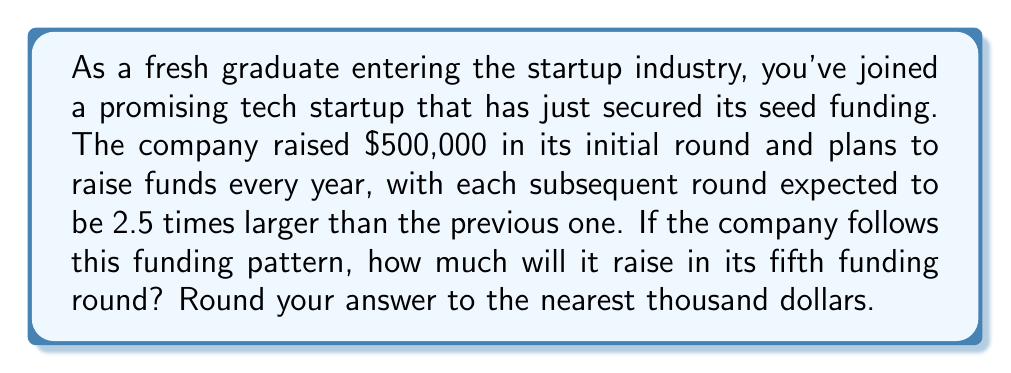Teach me how to tackle this problem. Let's approach this problem using a geometric sequence:

1) First, identify the components of the geometric sequence:
   - $a_1 = 500,000$ (initial term, seed funding)
   - $r = 2.5$ (common ratio, each round is 2.5 times larger)
   - We need to find $a_5$ (5th term, fifth funding round)

2) The formula for the nth term of a geometric sequence is:
   $a_n = a_1 \cdot r^{n-1}$

3) Substituting our values:
   $a_5 = 500,000 \cdot 2.5^{5-1}$
   $a_5 = 500,000 \cdot 2.5^4$

4) Calculate $2.5^4$:
   $2.5^4 = 2.5 \cdot 2.5 \cdot 2.5 \cdot 2.5 = 39.0625$

5) Multiply:
   $a_5 = 500,000 \cdot 39.0625 = 19,531,250$

6) Round to the nearest thousand:
   $19,531,250 \approx 19,531,000$

Therefore, the company will raise approximately $19,531,000 in its fifth funding round.
Answer: $19,531,000 